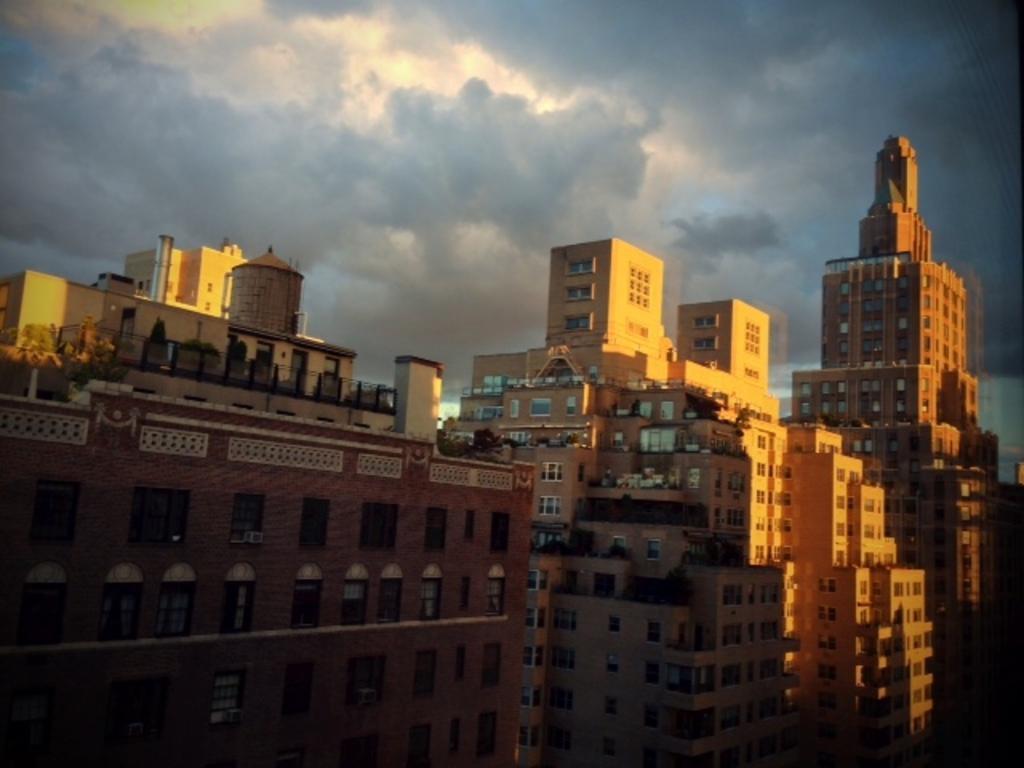Please provide a concise description of this image. In this image, we can see buildings and at the top, there are clouds in the sky. 